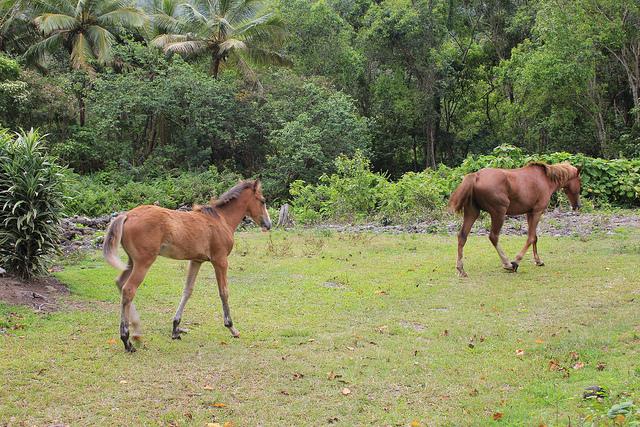Is one of the horses sleeping?
Short answer required. No. Is there something for the horses to graze on?
Quick response, please. Yes. How many horses are grazing?
Quick response, please. 2. Are these wild horses?
Concise answer only. Yes. Why are the horses heads bent down?
Short answer required. Walking. How many animals are shown?
Give a very brief answer. 2. How many horses are adults in this image?
Concise answer only. 2. 